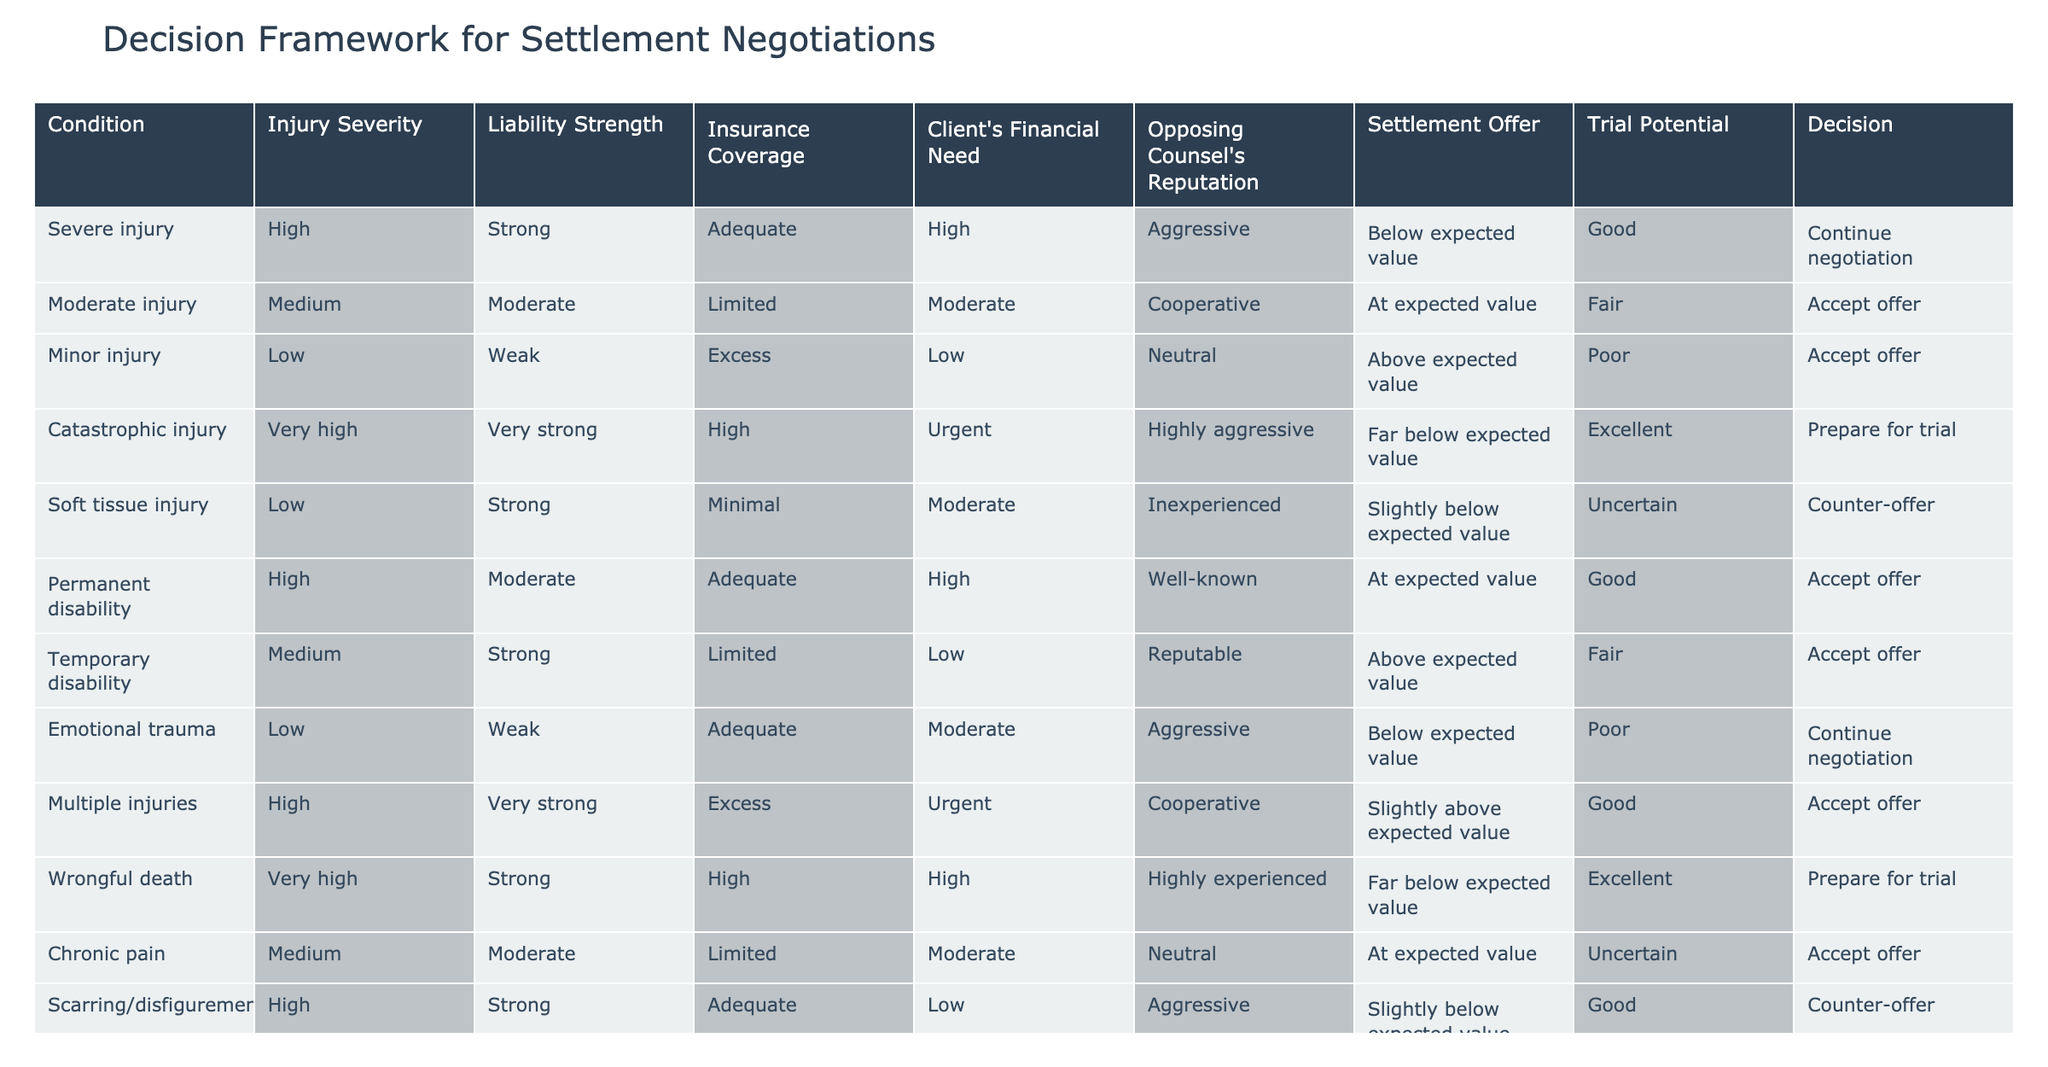What's the settlement offer for a spinal cord injury? The table indicates that the settlement offer for a spinal cord injury is "Far below expected value." This information is directly retrieved from the "Settlement Offer" column for the corresponding injury severity.
Answer: Far below expected value What is the trial potential for a client with a catastrophic injury? The "Trial Potential" column indicates that the trial potential for catastrophic injury is "Excellent," based on the specific condition listed in the table.
Answer: Excellent How many conditions have "High" severity and a "Strong" liability strength? We count the occurrences of conditions with "High" severity and "Strong" liability strength in the table. Two conditions match: Severe injury and Traumatic brain injury. Therefore, the total count is 2.
Answer: 2 Is the opposing counsel's reputation noted as "Aggressive" for any conditions? Looking through the "Opposing Counsel's Reputation" column, "Aggressive" appears for three conditions: Severe injury, Emotional trauma, and Traumatic brain injury. Thus, the answer is yes.
Answer: Yes For conditions with "Low" injury severity, what is the average insurance coverage level? The conditions with "Low" injury severity are: Minor injury (Excess), Emotional trauma (Adequate), Whiplash (Minimal). We assign values: Excess = 3, Adequate = 2, Minimal = 1. The sum is 3 + 2 + 1 = 6, and the average is 6/3 = 2.
Answer: 2 In cases of "Urgent" financial need, how many conditions result in preparing for trial? We examine the "Client's Financial Need" column for "Urgent" and note the conditions: Wrongful death and Spinal cord injury both lead to the decision to "Prepare for trial." Therefore, there are two conditions.
Answer: 2 What decision is recommended for a case with a permanent disability? The table states that for a permanent disability, the recommended decision is "Accept offer." This is directly found in the "Decision" column corresponding to that injury condition.
Answer: Accept offer What is the maximum injury severity level among all the conditions listed? By reviewing the "Injury Severity" column, we identify that "Very high" is the maximum level present in the data. We find this severity level for catastrophic injury and spinal cord injury.
Answer: Very high Are there any conditions where the settlement offer is above expected value? Looking at the "Settlement Offer" column, we can see two conditions with the settlement offer labeled as above expected value: Temporary disability and Multiple injuries. Therefore, the answer is yes.
Answer: Yes 